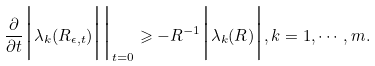<formula> <loc_0><loc_0><loc_500><loc_500>\frac { \partial } { \partial t } \Big | \lambda _ { k } ( R _ { \epsilon , t } ) \Big | \Big | _ { t = 0 } \geqslant - R ^ { - 1 } \Big | \lambda _ { k } ( R ) \Big | , k = 1 , \cdots , m .</formula> 